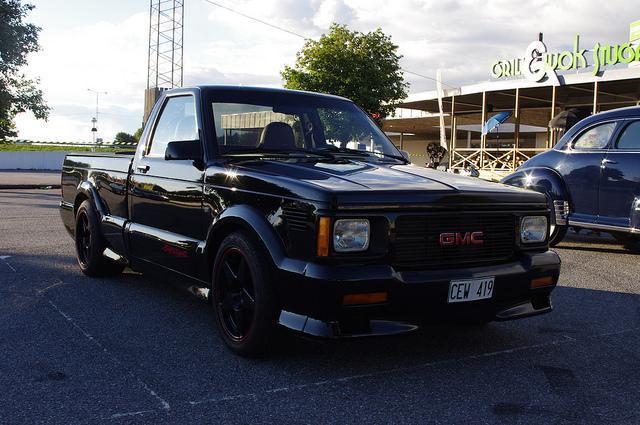How many beds are in the room?
Give a very brief answer. 0. 